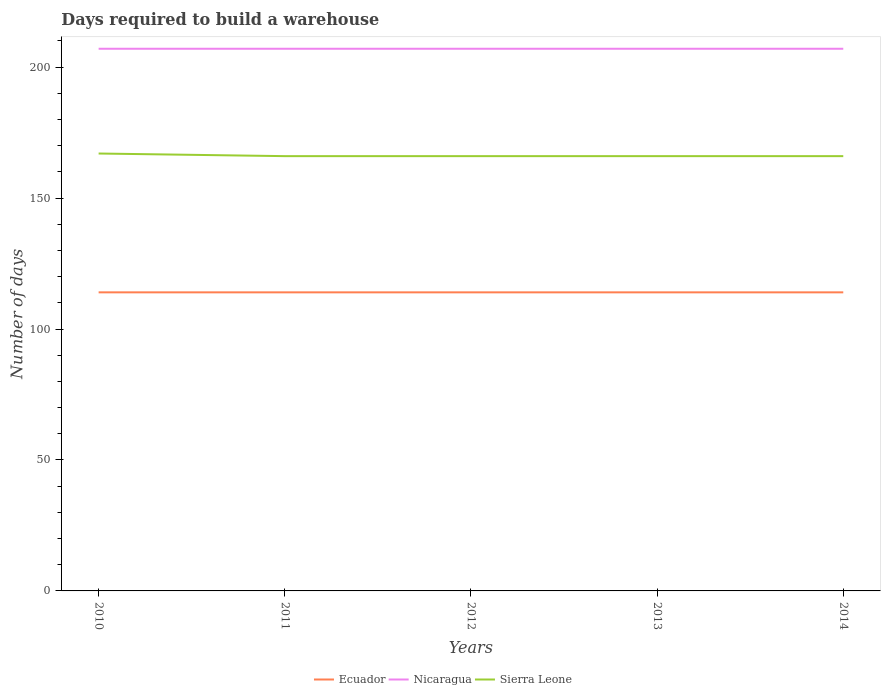How many different coloured lines are there?
Offer a very short reply. 3. Does the line corresponding to Nicaragua intersect with the line corresponding to Sierra Leone?
Offer a very short reply. No. Is the number of lines equal to the number of legend labels?
Your answer should be compact. Yes. Across all years, what is the maximum days required to build a warehouse in in Ecuador?
Your answer should be very brief. 114. In which year was the days required to build a warehouse in in Ecuador maximum?
Your answer should be very brief. 2010. What is the total days required to build a warehouse in in Sierra Leone in the graph?
Your answer should be compact. 1. What is the difference between the highest and the second highest days required to build a warehouse in in Sierra Leone?
Provide a short and direct response. 1. What is the difference between the highest and the lowest days required to build a warehouse in in Nicaragua?
Your answer should be very brief. 0. How many years are there in the graph?
Give a very brief answer. 5. What is the difference between two consecutive major ticks on the Y-axis?
Ensure brevity in your answer.  50. Does the graph contain any zero values?
Give a very brief answer. No. How are the legend labels stacked?
Your answer should be very brief. Horizontal. What is the title of the graph?
Your answer should be compact. Days required to build a warehouse. Does "Yemen, Rep." appear as one of the legend labels in the graph?
Ensure brevity in your answer.  No. What is the label or title of the X-axis?
Give a very brief answer. Years. What is the label or title of the Y-axis?
Provide a succinct answer. Number of days. What is the Number of days of Ecuador in 2010?
Your response must be concise. 114. What is the Number of days in Nicaragua in 2010?
Keep it short and to the point. 207. What is the Number of days in Sierra Leone in 2010?
Your answer should be very brief. 167. What is the Number of days of Ecuador in 2011?
Your response must be concise. 114. What is the Number of days in Nicaragua in 2011?
Your answer should be compact. 207. What is the Number of days in Sierra Leone in 2011?
Your response must be concise. 166. What is the Number of days of Ecuador in 2012?
Make the answer very short. 114. What is the Number of days in Nicaragua in 2012?
Offer a very short reply. 207. What is the Number of days in Sierra Leone in 2012?
Your answer should be compact. 166. What is the Number of days of Ecuador in 2013?
Keep it short and to the point. 114. What is the Number of days in Nicaragua in 2013?
Keep it short and to the point. 207. What is the Number of days in Sierra Leone in 2013?
Provide a succinct answer. 166. What is the Number of days of Ecuador in 2014?
Provide a succinct answer. 114. What is the Number of days of Nicaragua in 2014?
Your response must be concise. 207. What is the Number of days in Sierra Leone in 2014?
Your answer should be very brief. 166. Across all years, what is the maximum Number of days of Ecuador?
Give a very brief answer. 114. Across all years, what is the maximum Number of days of Nicaragua?
Give a very brief answer. 207. Across all years, what is the maximum Number of days of Sierra Leone?
Make the answer very short. 167. Across all years, what is the minimum Number of days of Ecuador?
Make the answer very short. 114. Across all years, what is the minimum Number of days in Nicaragua?
Make the answer very short. 207. Across all years, what is the minimum Number of days of Sierra Leone?
Offer a very short reply. 166. What is the total Number of days in Ecuador in the graph?
Ensure brevity in your answer.  570. What is the total Number of days in Nicaragua in the graph?
Provide a short and direct response. 1035. What is the total Number of days in Sierra Leone in the graph?
Offer a terse response. 831. What is the difference between the Number of days of Ecuador in 2010 and that in 2011?
Your answer should be very brief. 0. What is the difference between the Number of days in Nicaragua in 2010 and that in 2011?
Offer a very short reply. 0. What is the difference between the Number of days of Sierra Leone in 2010 and that in 2011?
Ensure brevity in your answer.  1. What is the difference between the Number of days of Ecuador in 2010 and that in 2012?
Give a very brief answer. 0. What is the difference between the Number of days in Ecuador in 2010 and that in 2013?
Offer a very short reply. 0. What is the difference between the Number of days of Sierra Leone in 2010 and that in 2013?
Make the answer very short. 1. What is the difference between the Number of days of Ecuador in 2010 and that in 2014?
Keep it short and to the point. 0. What is the difference between the Number of days of Sierra Leone in 2010 and that in 2014?
Your response must be concise. 1. What is the difference between the Number of days in Ecuador in 2011 and that in 2012?
Provide a short and direct response. 0. What is the difference between the Number of days of Sierra Leone in 2011 and that in 2012?
Provide a short and direct response. 0. What is the difference between the Number of days in Ecuador in 2011 and that in 2014?
Give a very brief answer. 0. What is the difference between the Number of days in Nicaragua in 2011 and that in 2014?
Keep it short and to the point. 0. What is the difference between the Number of days of Sierra Leone in 2011 and that in 2014?
Offer a very short reply. 0. What is the difference between the Number of days in Ecuador in 2012 and that in 2013?
Provide a succinct answer. 0. What is the difference between the Number of days of Nicaragua in 2012 and that in 2013?
Your answer should be compact. 0. What is the difference between the Number of days of Nicaragua in 2012 and that in 2014?
Make the answer very short. 0. What is the difference between the Number of days of Sierra Leone in 2012 and that in 2014?
Keep it short and to the point. 0. What is the difference between the Number of days in Sierra Leone in 2013 and that in 2014?
Your response must be concise. 0. What is the difference between the Number of days of Ecuador in 2010 and the Number of days of Nicaragua in 2011?
Keep it short and to the point. -93. What is the difference between the Number of days of Ecuador in 2010 and the Number of days of Sierra Leone in 2011?
Provide a short and direct response. -52. What is the difference between the Number of days in Nicaragua in 2010 and the Number of days in Sierra Leone in 2011?
Your answer should be compact. 41. What is the difference between the Number of days in Ecuador in 2010 and the Number of days in Nicaragua in 2012?
Ensure brevity in your answer.  -93. What is the difference between the Number of days in Ecuador in 2010 and the Number of days in Sierra Leone in 2012?
Your answer should be very brief. -52. What is the difference between the Number of days in Nicaragua in 2010 and the Number of days in Sierra Leone in 2012?
Keep it short and to the point. 41. What is the difference between the Number of days of Ecuador in 2010 and the Number of days of Nicaragua in 2013?
Offer a very short reply. -93. What is the difference between the Number of days in Ecuador in 2010 and the Number of days in Sierra Leone in 2013?
Provide a short and direct response. -52. What is the difference between the Number of days in Nicaragua in 2010 and the Number of days in Sierra Leone in 2013?
Ensure brevity in your answer.  41. What is the difference between the Number of days in Ecuador in 2010 and the Number of days in Nicaragua in 2014?
Give a very brief answer. -93. What is the difference between the Number of days of Ecuador in 2010 and the Number of days of Sierra Leone in 2014?
Your answer should be compact. -52. What is the difference between the Number of days in Ecuador in 2011 and the Number of days in Nicaragua in 2012?
Provide a short and direct response. -93. What is the difference between the Number of days in Ecuador in 2011 and the Number of days in Sierra Leone in 2012?
Your response must be concise. -52. What is the difference between the Number of days in Ecuador in 2011 and the Number of days in Nicaragua in 2013?
Ensure brevity in your answer.  -93. What is the difference between the Number of days in Ecuador in 2011 and the Number of days in Sierra Leone in 2013?
Your answer should be compact. -52. What is the difference between the Number of days of Nicaragua in 2011 and the Number of days of Sierra Leone in 2013?
Offer a very short reply. 41. What is the difference between the Number of days in Ecuador in 2011 and the Number of days in Nicaragua in 2014?
Give a very brief answer. -93. What is the difference between the Number of days of Ecuador in 2011 and the Number of days of Sierra Leone in 2014?
Your response must be concise. -52. What is the difference between the Number of days in Nicaragua in 2011 and the Number of days in Sierra Leone in 2014?
Provide a short and direct response. 41. What is the difference between the Number of days of Ecuador in 2012 and the Number of days of Nicaragua in 2013?
Keep it short and to the point. -93. What is the difference between the Number of days of Ecuador in 2012 and the Number of days of Sierra Leone in 2013?
Offer a very short reply. -52. What is the difference between the Number of days of Nicaragua in 2012 and the Number of days of Sierra Leone in 2013?
Make the answer very short. 41. What is the difference between the Number of days in Ecuador in 2012 and the Number of days in Nicaragua in 2014?
Keep it short and to the point. -93. What is the difference between the Number of days of Ecuador in 2012 and the Number of days of Sierra Leone in 2014?
Your answer should be compact. -52. What is the difference between the Number of days in Ecuador in 2013 and the Number of days in Nicaragua in 2014?
Provide a succinct answer. -93. What is the difference between the Number of days in Ecuador in 2013 and the Number of days in Sierra Leone in 2014?
Offer a very short reply. -52. What is the average Number of days in Ecuador per year?
Provide a succinct answer. 114. What is the average Number of days of Nicaragua per year?
Offer a terse response. 207. What is the average Number of days of Sierra Leone per year?
Offer a terse response. 166.2. In the year 2010, what is the difference between the Number of days in Ecuador and Number of days in Nicaragua?
Offer a terse response. -93. In the year 2010, what is the difference between the Number of days of Ecuador and Number of days of Sierra Leone?
Your response must be concise. -53. In the year 2011, what is the difference between the Number of days in Ecuador and Number of days in Nicaragua?
Make the answer very short. -93. In the year 2011, what is the difference between the Number of days of Ecuador and Number of days of Sierra Leone?
Provide a short and direct response. -52. In the year 2011, what is the difference between the Number of days in Nicaragua and Number of days in Sierra Leone?
Ensure brevity in your answer.  41. In the year 2012, what is the difference between the Number of days in Ecuador and Number of days in Nicaragua?
Your answer should be very brief. -93. In the year 2012, what is the difference between the Number of days in Ecuador and Number of days in Sierra Leone?
Offer a terse response. -52. In the year 2013, what is the difference between the Number of days in Ecuador and Number of days in Nicaragua?
Make the answer very short. -93. In the year 2013, what is the difference between the Number of days in Ecuador and Number of days in Sierra Leone?
Your response must be concise. -52. In the year 2013, what is the difference between the Number of days of Nicaragua and Number of days of Sierra Leone?
Your answer should be very brief. 41. In the year 2014, what is the difference between the Number of days in Ecuador and Number of days in Nicaragua?
Offer a very short reply. -93. In the year 2014, what is the difference between the Number of days of Ecuador and Number of days of Sierra Leone?
Your answer should be compact. -52. What is the ratio of the Number of days in Ecuador in 2010 to that in 2011?
Your answer should be very brief. 1. What is the ratio of the Number of days of Nicaragua in 2010 to that in 2011?
Your answer should be very brief. 1. What is the ratio of the Number of days of Nicaragua in 2010 to that in 2013?
Give a very brief answer. 1. What is the ratio of the Number of days of Ecuador in 2010 to that in 2014?
Your answer should be compact. 1. What is the ratio of the Number of days of Nicaragua in 2010 to that in 2014?
Offer a terse response. 1. What is the ratio of the Number of days in Ecuador in 2011 to that in 2012?
Your answer should be compact. 1. What is the ratio of the Number of days of Sierra Leone in 2011 to that in 2012?
Your answer should be very brief. 1. What is the ratio of the Number of days of Ecuador in 2011 to that in 2013?
Give a very brief answer. 1. What is the ratio of the Number of days of Nicaragua in 2011 to that in 2013?
Make the answer very short. 1. What is the ratio of the Number of days in Sierra Leone in 2011 to that in 2013?
Your response must be concise. 1. What is the ratio of the Number of days of Ecuador in 2011 to that in 2014?
Your answer should be very brief. 1. What is the ratio of the Number of days in Sierra Leone in 2011 to that in 2014?
Provide a short and direct response. 1. What is the ratio of the Number of days in Ecuador in 2012 to that in 2013?
Make the answer very short. 1. What is the ratio of the Number of days in Ecuador in 2012 to that in 2014?
Provide a short and direct response. 1. What is the ratio of the Number of days of Ecuador in 2013 to that in 2014?
Ensure brevity in your answer.  1. What is the difference between the highest and the second highest Number of days of Ecuador?
Your response must be concise. 0. What is the difference between the highest and the second highest Number of days in Sierra Leone?
Keep it short and to the point. 1. What is the difference between the highest and the lowest Number of days of Nicaragua?
Provide a succinct answer. 0. 